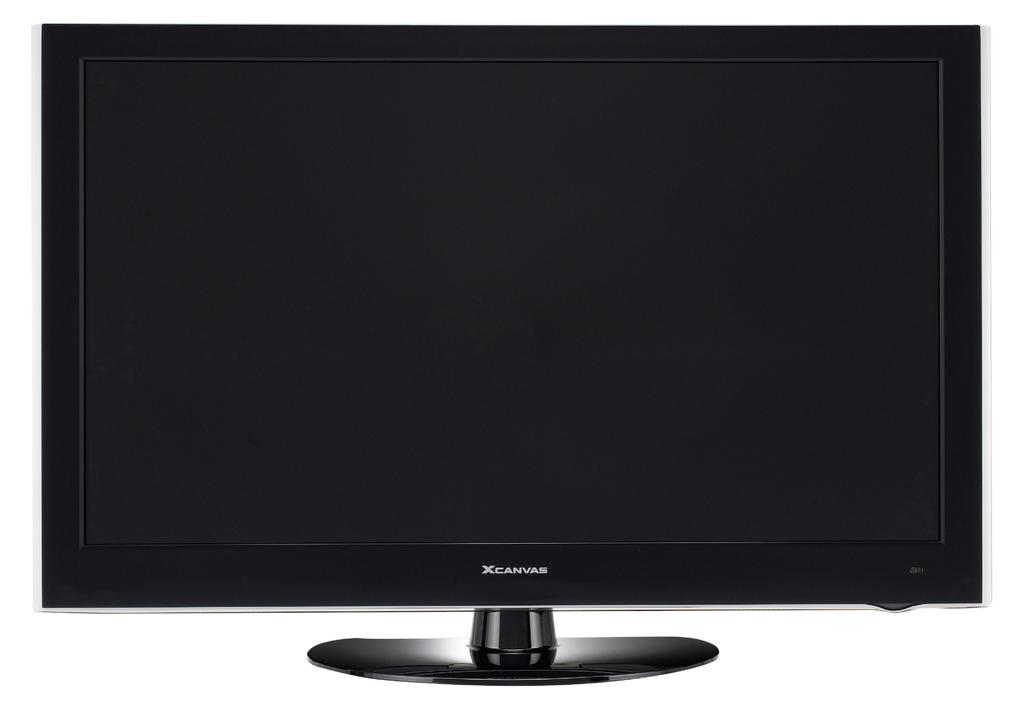What brand of monitor is this?
Your answer should be very brief. Xcanvas. What letter does the name begin with?
Your answer should be compact. X. 